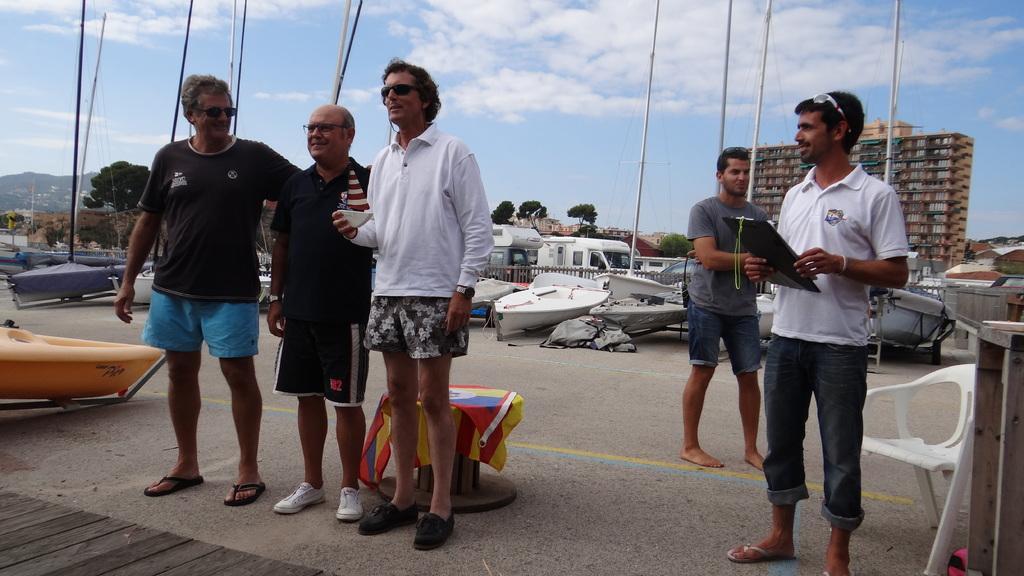How would you summarize this image in a sentence or two? In this image there are some people who are standing, and also in the background there are some boards and some vehicles, trees, buildings houses and some poles. And at the top of the image there is sky, and at the bottom there is a walkway and on the right side there is one chair and in the center there is one stool. On the stool there is one cloth. 